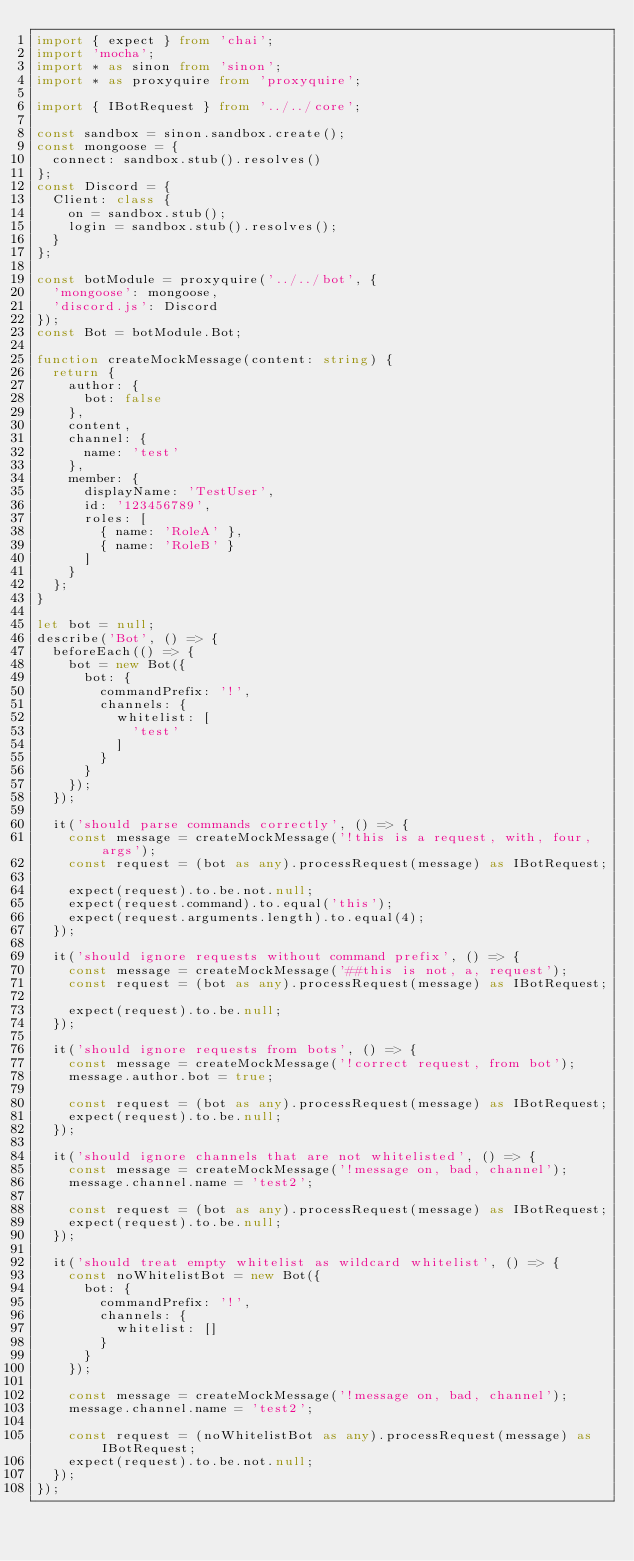Convert code to text. <code><loc_0><loc_0><loc_500><loc_500><_TypeScript_>import { expect } from 'chai';
import 'mocha';
import * as sinon from 'sinon';
import * as proxyquire from 'proxyquire';

import { IBotRequest } from '../../core';

const sandbox = sinon.sandbox.create();
const mongoose = {
  connect: sandbox.stub().resolves()
};
const Discord = {
  Client: class {
    on = sandbox.stub();
    login = sandbox.stub().resolves();
  }
};

const botModule = proxyquire('../../bot', {
  'mongoose': mongoose,
  'discord.js': Discord
});
const Bot = botModule.Bot;

function createMockMessage(content: string) {
  return {
    author: {
      bot: false
    },
    content,
    channel: {
      name: 'test'
    },
    member: {
      displayName: 'TestUser',
      id: '123456789',
      roles: [
        { name: 'RoleA' },
        { name: 'RoleB' }
      ]
    }
  };
}

let bot = null;
describe('Bot', () => {
  beforeEach(() => {
    bot = new Bot({
      bot: {
        commandPrefix: '!',
        channels: {
          whitelist: [
            'test'
          ]
        }
      }
    });
  });

  it('should parse commands correctly', () => {
    const message = createMockMessage('!this is a request, with, four, args');
    const request = (bot as any).processRequest(message) as IBotRequest;

    expect(request).to.be.not.null;
    expect(request.command).to.equal('this');
    expect(request.arguments.length).to.equal(4);
  });

  it('should ignore requests without command prefix', () => {
    const message = createMockMessage('##this is not, a, request');
    const request = (bot as any).processRequest(message) as IBotRequest;

    expect(request).to.be.null;
  });

  it('should ignore requests from bots', () => {
    const message = createMockMessage('!correct request, from bot');
    message.author.bot = true;

    const request = (bot as any).processRequest(message) as IBotRequest;
    expect(request).to.be.null;
  });

  it('should ignore channels that are not whitelisted', () => {
    const message = createMockMessage('!message on, bad, channel');
    message.channel.name = 'test2';

    const request = (bot as any).processRequest(message) as IBotRequest;
    expect(request).to.be.null;
  });

  it('should treat empty whitelist as wildcard whitelist', () => {
    const noWhitelistBot = new Bot({
      bot: {
        commandPrefix: '!',
        channels: {
          whitelist: []
        }
      }
    });

    const message = createMockMessage('!message on, bad, channel');
    message.channel.name = 'test2';

    const request = (noWhitelistBot as any).processRequest(message) as IBotRequest;
    expect(request).to.be.not.null;
  });
});
</code> 